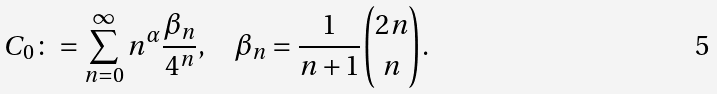<formula> <loc_0><loc_0><loc_500><loc_500>C _ { 0 } \colon = \sum _ { n = 0 } ^ { \infty } n ^ { \alpha } \frac { \beta _ { n } } { 4 ^ { n } } , \quad \beta _ { n } = \frac { 1 } { n + 1 } \binom { 2 n } { n } .</formula> 